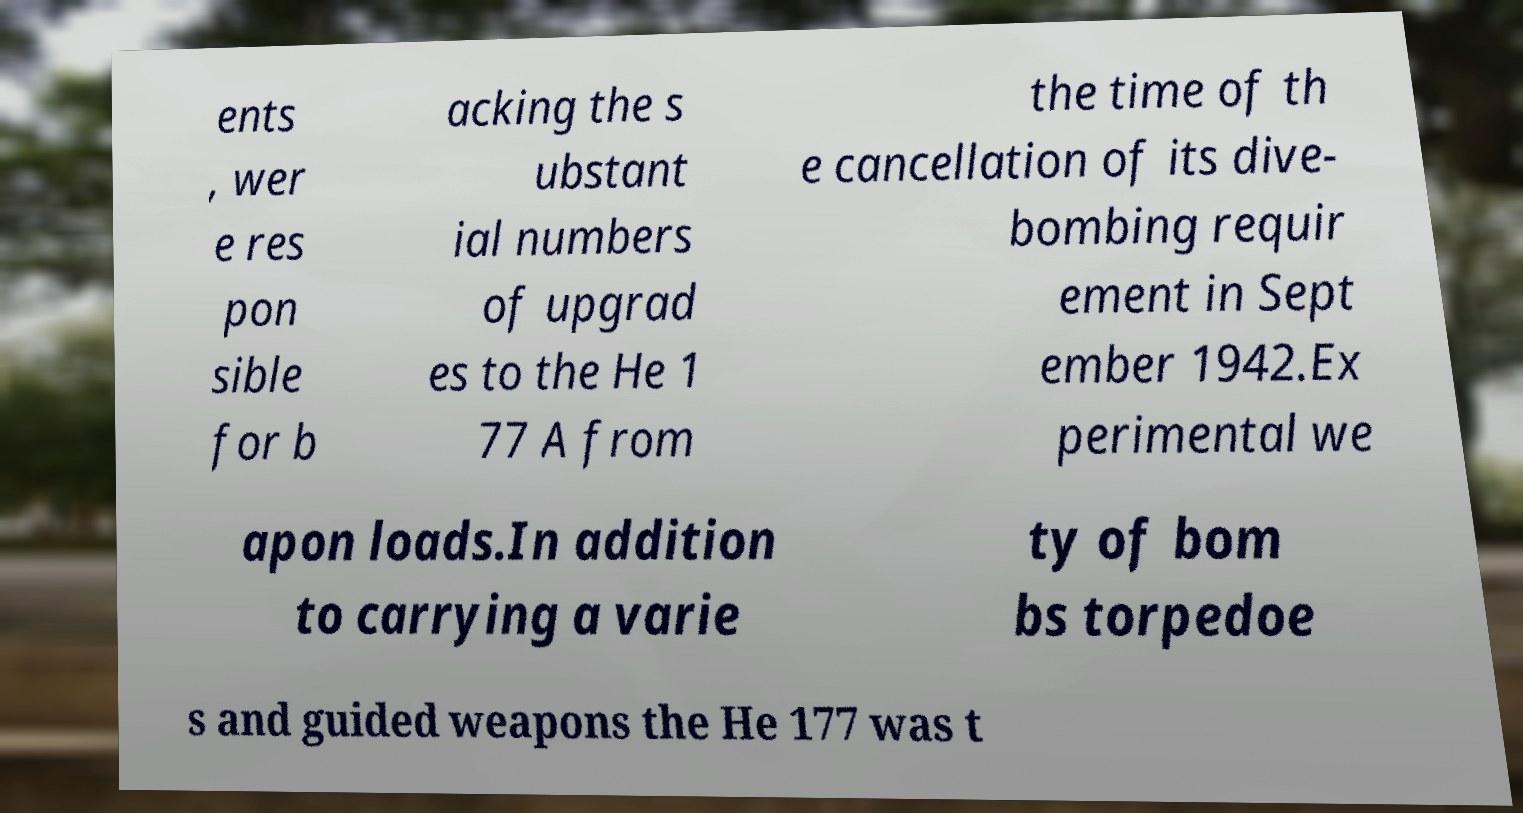Can you accurately transcribe the text from the provided image for me? ents , wer e res pon sible for b acking the s ubstant ial numbers of upgrad es to the He 1 77 A from the time of th e cancellation of its dive- bombing requir ement in Sept ember 1942.Ex perimental we apon loads.In addition to carrying a varie ty of bom bs torpedoe s and guided weapons the He 177 was t 